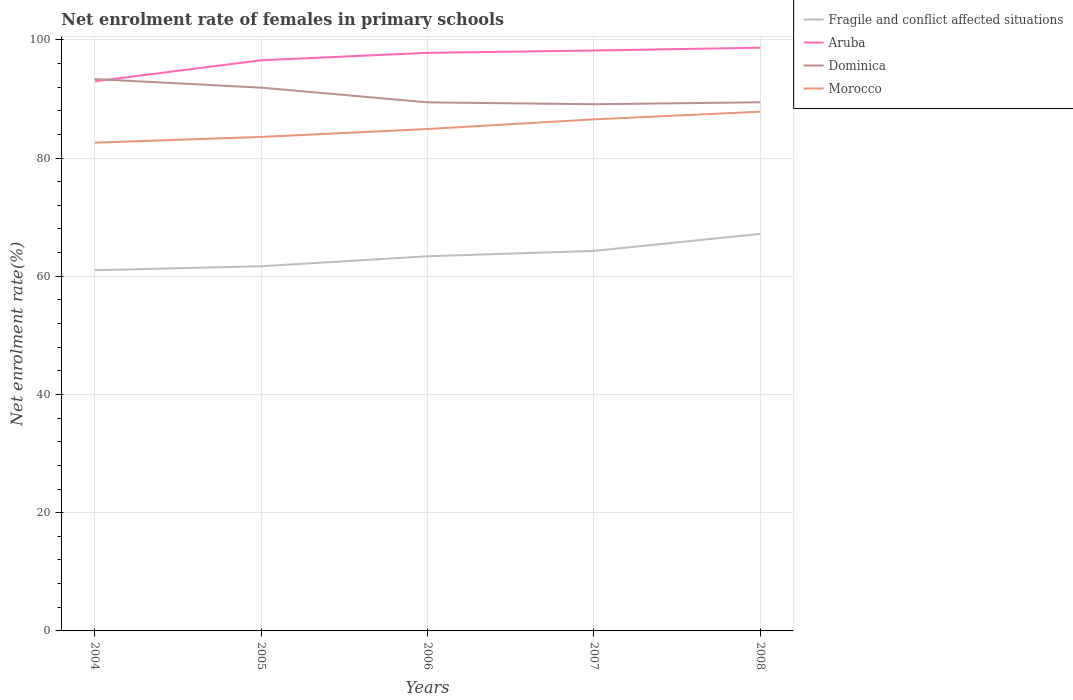Does the line corresponding to Dominica intersect with the line corresponding to Fragile and conflict affected situations?
Give a very brief answer. No. Is the number of lines equal to the number of legend labels?
Offer a very short reply. Yes. Across all years, what is the maximum net enrolment rate of females in primary schools in Fragile and conflict affected situations?
Your answer should be compact. 61.02. What is the total net enrolment rate of females in primary schools in Fragile and conflict affected situations in the graph?
Provide a short and direct response. -5.48. What is the difference between the highest and the second highest net enrolment rate of females in primary schools in Fragile and conflict affected situations?
Offer a very short reply. 6.15. What is the difference between the highest and the lowest net enrolment rate of females in primary schools in Fragile and conflict affected situations?
Your answer should be compact. 2. How many lines are there?
Give a very brief answer. 4. What is the difference between two consecutive major ticks on the Y-axis?
Your answer should be very brief. 20. Are the values on the major ticks of Y-axis written in scientific E-notation?
Provide a succinct answer. No. How many legend labels are there?
Offer a terse response. 4. What is the title of the graph?
Your answer should be very brief. Net enrolment rate of females in primary schools. Does "Madagascar" appear as one of the legend labels in the graph?
Give a very brief answer. No. What is the label or title of the X-axis?
Keep it short and to the point. Years. What is the label or title of the Y-axis?
Your answer should be compact. Net enrolment rate(%). What is the Net enrolment rate(%) of Fragile and conflict affected situations in 2004?
Your answer should be compact. 61.02. What is the Net enrolment rate(%) in Aruba in 2004?
Keep it short and to the point. 92.98. What is the Net enrolment rate(%) of Dominica in 2004?
Make the answer very short. 93.36. What is the Net enrolment rate(%) of Morocco in 2004?
Offer a terse response. 82.59. What is the Net enrolment rate(%) in Fragile and conflict affected situations in 2005?
Provide a succinct answer. 61.69. What is the Net enrolment rate(%) of Aruba in 2005?
Your answer should be very brief. 96.54. What is the Net enrolment rate(%) of Dominica in 2005?
Offer a terse response. 91.91. What is the Net enrolment rate(%) of Morocco in 2005?
Your answer should be compact. 83.57. What is the Net enrolment rate(%) in Fragile and conflict affected situations in 2006?
Your answer should be very brief. 63.38. What is the Net enrolment rate(%) in Aruba in 2006?
Keep it short and to the point. 97.8. What is the Net enrolment rate(%) of Dominica in 2006?
Your answer should be compact. 89.42. What is the Net enrolment rate(%) of Morocco in 2006?
Provide a succinct answer. 84.91. What is the Net enrolment rate(%) of Fragile and conflict affected situations in 2007?
Give a very brief answer. 64.29. What is the Net enrolment rate(%) in Aruba in 2007?
Keep it short and to the point. 98.19. What is the Net enrolment rate(%) in Dominica in 2007?
Your response must be concise. 89.1. What is the Net enrolment rate(%) in Morocco in 2007?
Your response must be concise. 86.54. What is the Net enrolment rate(%) of Fragile and conflict affected situations in 2008?
Your response must be concise. 67.17. What is the Net enrolment rate(%) of Aruba in 2008?
Your answer should be very brief. 98.67. What is the Net enrolment rate(%) in Dominica in 2008?
Ensure brevity in your answer.  89.43. What is the Net enrolment rate(%) of Morocco in 2008?
Provide a succinct answer. 87.84. Across all years, what is the maximum Net enrolment rate(%) in Fragile and conflict affected situations?
Provide a short and direct response. 67.17. Across all years, what is the maximum Net enrolment rate(%) in Aruba?
Give a very brief answer. 98.67. Across all years, what is the maximum Net enrolment rate(%) of Dominica?
Ensure brevity in your answer.  93.36. Across all years, what is the maximum Net enrolment rate(%) in Morocco?
Your answer should be very brief. 87.84. Across all years, what is the minimum Net enrolment rate(%) of Fragile and conflict affected situations?
Offer a terse response. 61.02. Across all years, what is the minimum Net enrolment rate(%) in Aruba?
Give a very brief answer. 92.98. Across all years, what is the minimum Net enrolment rate(%) in Dominica?
Offer a very short reply. 89.1. Across all years, what is the minimum Net enrolment rate(%) in Morocco?
Give a very brief answer. 82.59. What is the total Net enrolment rate(%) of Fragile and conflict affected situations in the graph?
Your answer should be very brief. 317.56. What is the total Net enrolment rate(%) of Aruba in the graph?
Ensure brevity in your answer.  484.17. What is the total Net enrolment rate(%) in Dominica in the graph?
Offer a very short reply. 453.22. What is the total Net enrolment rate(%) of Morocco in the graph?
Make the answer very short. 425.46. What is the difference between the Net enrolment rate(%) in Fragile and conflict affected situations in 2004 and that in 2005?
Your answer should be compact. -0.67. What is the difference between the Net enrolment rate(%) of Aruba in 2004 and that in 2005?
Give a very brief answer. -3.57. What is the difference between the Net enrolment rate(%) in Dominica in 2004 and that in 2005?
Your response must be concise. 1.45. What is the difference between the Net enrolment rate(%) in Morocco in 2004 and that in 2005?
Your response must be concise. -0.98. What is the difference between the Net enrolment rate(%) of Fragile and conflict affected situations in 2004 and that in 2006?
Offer a very short reply. -2.36. What is the difference between the Net enrolment rate(%) in Aruba in 2004 and that in 2006?
Make the answer very short. -4.82. What is the difference between the Net enrolment rate(%) in Dominica in 2004 and that in 2006?
Make the answer very short. 3.94. What is the difference between the Net enrolment rate(%) of Morocco in 2004 and that in 2006?
Keep it short and to the point. -2.32. What is the difference between the Net enrolment rate(%) of Fragile and conflict affected situations in 2004 and that in 2007?
Provide a short and direct response. -3.27. What is the difference between the Net enrolment rate(%) of Aruba in 2004 and that in 2007?
Provide a short and direct response. -5.22. What is the difference between the Net enrolment rate(%) in Dominica in 2004 and that in 2007?
Provide a short and direct response. 4.26. What is the difference between the Net enrolment rate(%) in Morocco in 2004 and that in 2007?
Make the answer very short. -3.95. What is the difference between the Net enrolment rate(%) in Fragile and conflict affected situations in 2004 and that in 2008?
Make the answer very short. -6.15. What is the difference between the Net enrolment rate(%) in Aruba in 2004 and that in 2008?
Provide a succinct answer. -5.69. What is the difference between the Net enrolment rate(%) in Dominica in 2004 and that in 2008?
Provide a short and direct response. 3.93. What is the difference between the Net enrolment rate(%) of Morocco in 2004 and that in 2008?
Make the answer very short. -5.24. What is the difference between the Net enrolment rate(%) in Fragile and conflict affected situations in 2005 and that in 2006?
Provide a short and direct response. -1.69. What is the difference between the Net enrolment rate(%) in Aruba in 2005 and that in 2006?
Make the answer very short. -1.26. What is the difference between the Net enrolment rate(%) in Dominica in 2005 and that in 2006?
Offer a terse response. 2.49. What is the difference between the Net enrolment rate(%) of Morocco in 2005 and that in 2006?
Offer a terse response. -1.34. What is the difference between the Net enrolment rate(%) in Fragile and conflict affected situations in 2005 and that in 2007?
Make the answer very short. -2.6. What is the difference between the Net enrolment rate(%) of Aruba in 2005 and that in 2007?
Your answer should be very brief. -1.65. What is the difference between the Net enrolment rate(%) of Dominica in 2005 and that in 2007?
Give a very brief answer. 2.81. What is the difference between the Net enrolment rate(%) of Morocco in 2005 and that in 2007?
Your answer should be compact. -2.97. What is the difference between the Net enrolment rate(%) in Fragile and conflict affected situations in 2005 and that in 2008?
Provide a short and direct response. -5.48. What is the difference between the Net enrolment rate(%) of Aruba in 2005 and that in 2008?
Keep it short and to the point. -2.12. What is the difference between the Net enrolment rate(%) of Dominica in 2005 and that in 2008?
Ensure brevity in your answer.  2.48. What is the difference between the Net enrolment rate(%) in Morocco in 2005 and that in 2008?
Your response must be concise. -4.27. What is the difference between the Net enrolment rate(%) of Fragile and conflict affected situations in 2006 and that in 2007?
Ensure brevity in your answer.  -0.91. What is the difference between the Net enrolment rate(%) in Aruba in 2006 and that in 2007?
Your answer should be compact. -0.39. What is the difference between the Net enrolment rate(%) in Dominica in 2006 and that in 2007?
Give a very brief answer. 0.32. What is the difference between the Net enrolment rate(%) of Morocco in 2006 and that in 2007?
Ensure brevity in your answer.  -1.63. What is the difference between the Net enrolment rate(%) in Fragile and conflict affected situations in 2006 and that in 2008?
Make the answer very short. -3.79. What is the difference between the Net enrolment rate(%) of Aruba in 2006 and that in 2008?
Make the answer very short. -0.87. What is the difference between the Net enrolment rate(%) in Dominica in 2006 and that in 2008?
Keep it short and to the point. -0.01. What is the difference between the Net enrolment rate(%) of Morocco in 2006 and that in 2008?
Your answer should be compact. -2.93. What is the difference between the Net enrolment rate(%) of Fragile and conflict affected situations in 2007 and that in 2008?
Your answer should be very brief. -2.89. What is the difference between the Net enrolment rate(%) in Aruba in 2007 and that in 2008?
Your response must be concise. -0.48. What is the difference between the Net enrolment rate(%) of Dominica in 2007 and that in 2008?
Offer a terse response. -0.33. What is the difference between the Net enrolment rate(%) of Morocco in 2007 and that in 2008?
Your answer should be compact. -1.29. What is the difference between the Net enrolment rate(%) of Fragile and conflict affected situations in 2004 and the Net enrolment rate(%) of Aruba in 2005?
Keep it short and to the point. -35.52. What is the difference between the Net enrolment rate(%) in Fragile and conflict affected situations in 2004 and the Net enrolment rate(%) in Dominica in 2005?
Offer a terse response. -30.89. What is the difference between the Net enrolment rate(%) of Fragile and conflict affected situations in 2004 and the Net enrolment rate(%) of Morocco in 2005?
Your answer should be very brief. -22.55. What is the difference between the Net enrolment rate(%) in Aruba in 2004 and the Net enrolment rate(%) in Dominica in 2005?
Give a very brief answer. 1.07. What is the difference between the Net enrolment rate(%) in Aruba in 2004 and the Net enrolment rate(%) in Morocco in 2005?
Your answer should be compact. 9.4. What is the difference between the Net enrolment rate(%) of Dominica in 2004 and the Net enrolment rate(%) of Morocco in 2005?
Ensure brevity in your answer.  9.79. What is the difference between the Net enrolment rate(%) in Fragile and conflict affected situations in 2004 and the Net enrolment rate(%) in Aruba in 2006?
Give a very brief answer. -36.77. What is the difference between the Net enrolment rate(%) in Fragile and conflict affected situations in 2004 and the Net enrolment rate(%) in Dominica in 2006?
Your answer should be very brief. -28.4. What is the difference between the Net enrolment rate(%) of Fragile and conflict affected situations in 2004 and the Net enrolment rate(%) of Morocco in 2006?
Offer a very short reply. -23.89. What is the difference between the Net enrolment rate(%) in Aruba in 2004 and the Net enrolment rate(%) in Dominica in 2006?
Offer a terse response. 3.56. What is the difference between the Net enrolment rate(%) in Aruba in 2004 and the Net enrolment rate(%) in Morocco in 2006?
Give a very brief answer. 8.07. What is the difference between the Net enrolment rate(%) in Dominica in 2004 and the Net enrolment rate(%) in Morocco in 2006?
Offer a terse response. 8.45. What is the difference between the Net enrolment rate(%) of Fragile and conflict affected situations in 2004 and the Net enrolment rate(%) of Aruba in 2007?
Keep it short and to the point. -37.17. What is the difference between the Net enrolment rate(%) in Fragile and conflict affected situations in 2004 and the Net enrolment rate(%) in Dominica in 2007?
Keep it short and to the point. -28.08. What is the difference between the Net enrolment rate(%) in Fragile and conflict affected situations in 2004 and the Net enrolment rate(%) in Morocco in 2007?
Provide a short and direct response. -25.52. What is the difference between the Net enrolment rate(%) of Aruba in 2004 and the Net enrolment rate(%) of Dominica in 2007?
Offer a very short reply. 3.87. What is the difference between the Net enrolment rate(%) of Aruba in 2004 and the Net enrolment rate(%) of Morocco in 2007?
Provide a short and direct response. 6.43. What is the difference between the Net enrolment rate(%) in Dominica in 2004 and the Net enrolment rate(%) in Morocco in 2007?
Ensure brevity in your answer.  6.82. What is the difference between the Net enrolment rate(%) of Fragile and conflict affected situations in 2004 and the Net enrolment rate(%) of Aruba in 2008?
Offer a very short reply. -37.64. What is the difference between the Net enrolment rate(%) of Fragile and conflict affected situations in 2004 and the Net enrolment rate(%) of Dominica in 2008?
Provide a short and direct response. -28.41. What is the difference between the Net enrolment rate(%) of Fragile and conflict affected situations in 2004 and the Net enrolment rate(%) of Morocco in 2008?
Offer a terse response. -26.81. What is the difference between the Net enrolment rate(%) of Aruba in 2004 and the Net enrolment rate(%) of Dominica in 2008?
Your answer should be very brief. 3.54. What is the difference between the Net enrolment rate(%) of Aruba in 2004 and the Net enrolment rate(%) of Morocco in 2008?
Keep it short and to the point. 5.14. What is the difference between the Net enrolment rate(%) of Dominica in 2004 and the Net enrolment rate(%) of Morocco in 2008?
Give a very brief answer. 5.52. What is the difference between the Net enrolment rate(%) in Fragile and conflict affected situations in 2005 and the Net enrolment rate(%) in Aruba in 2006?
Make the answer very short. -36.11. What is the difference between the Net enrolment rate(%) in Fragile and conflict affected situations in 2005 and the Net enrolment rate(%) in Dominica in 2006?
Your answer should be compact. -27.73. What is the difference between the Net enrolment rate(%) in Fragile and conflict affected situations in 2005 and the Net enrolment rate(%) in Morocco in 2006?
Your answer should be very brief. -23.22. What is the difference between the Net enrolment rate(%) of Aruba in 2005 and the Net enrolment rate(%) of Dominica in 2006?
Your answer should be very brief. 7.12. What is the difference between the Net enrolment rate(%) in Aruba in 2005 and the Net enrolment rate(%) in Morocco in 2006?
Provide a succinct answer. 11.63. What is the difference between the Net enrolment rate(%) in Dominica in 2005 and the Net enrolment rate(%) in Morocco in 2006?
Ensure brevity in your answer.  7. What is the difference between the Net enrolment rate(%) of Fragile and conflict affected situations in 2005 and the Net enrolment rate(%) of Aruba in 2007?
Your answer should be compact. -36.5. What is the difference between the Net enrolment rate(%) of Fragile and conflict affected situations in 2005 and the Net enrolment rate(%) of Dominica in 2007?
Provide a short and direct response. -27.41. What is the difference between the Net enrolment rate(%) in Fragile and conflict affected situations in 2005 and the Net enrolment rate(%) in Morocco in 2007?
Your answer should be compact. -24.85. What is the difference between the Net enrolment rate(%) in Aruba in 2005 and the Net enrolment rate(%) in Dominica in 2007?
Give a very brief answer. 7.44. What is the difference between the Net enrolment rate(%) in Aruba in 2005 and the Net enrolment rate(%) in Morocco in 2007?
Ensure brevity in your answer.  10. What is the difference between the Net enrolment rate(%) of Dominica in 2005 and the Net enrolment rate(%) of Morocco in 2007?
Provide a short and direct response. 5.37. What is the difference between the Net enrolment rate(%) in Fragile and conflict affected situations in 2005 and the Net enrolment rate(%) in Aruba in 2008?
Your answer should be compact. -36.97. What is the difference between the Net enrolment rate(%) of Fragile and conflict affected situations in 2005 and the Net enrolment rate(%) of Dominica in 2008?
Give a very brief answer. -27.74. What is the difference between the Net enrolment rate(%) of Fragile and conflict affected situations in 2005 and the Net enrolment rate(%) of Morocco in 2008?
Offer a very short reply. -26.14. What is the difference between the Net enrolment rate(%) of Aruba in 2005 and the Net enrolment rate(%) of Dominica in 2008?
Make the answer very short. 7.11. What is the difference between the Net enrolment rate(%) in Aruba in 2005 and the Net enrolment rate(%) in Morocco in 2008?
Ensure brevity in your answer.  8.7. What is the difference between the Net enrolment rate(%) of Dominica in 2005 and the Net enrolment rate(%) of Morocco in 2008?
Ensure brevity in your answer.  4.07. What is the difference between the Net enrolment rate(%) of Fragile and conflict affected situations in 2006 and the Net enrolment rate(%) of Aruba in 2007?
Provide a short and direct response. -34.81. What is the difference between the Net enrolment rate(%) of Fragile and conflict affected situations in 2006 and the Net enrolment rate(%) of Dominica in 2007?
Provide a short and direct response. -25.72. What is the difference between the Net enrolment rate(%) of Fragile and conflict affected situations in 2006 and the Net enrolment rate(%) of Morocco in 2007?
Offer a very short reply. -23.16. What is the difference between the Net enrolment rate(%) of Aruba in 2006 and the Net enrolment rate(%) of Dominica in 2007?
Keep it short and to the point. 8.7. What is the difference between the Net enrolment rate(%) of Aruba in 2006 and the Net enrolment rate(%) of Morocco in 2007?
Your answer should be very brief. 11.25. What is the difference between the Net enrolment rate(%) in Dominica in 2006 and the Net enrolment rate(%) in Morocco in 2007?
Offer a terse response. 2.88. What is the difference between the Net enrolment rate(%) of Fragile and conflict affected situations in 2006 and the Net enrolment rate(%) of Aruba in 2008?
Your answer should be very brief. -35.28. What is the difference between the Net enrolment rate(%) of Fragile and conflict affected situations in 2006 and the Net enrolment rate(%) of Dominica in 2008?
Offer a terse response. -26.05. What is the difference between the Net enrolment rate(%) in Fragile and conflict affected situations in 2006 and the Net enrolment rate(%) in Morocco in 2008?
Your answer should be compact. -24.45. What is the difference between the Net enrolment rate(%) of Aruba in 2006 and the Net enrolment rate(%) of Dominica in 2008?
Offer a very short reply. 8.37. What is the difference between the Net enrolment rate(%) of Aruba in 2006 and the Net enrolment rate(%) of Morocco in 2008?
Keep it short and to the point. 9.96. What is the difference between the Net enrolment rate(%) in Dominica in 2006 and the Net enrolment rate(%) in Morocco in 2008?
Offer a very short reply. 1.58. What is the difference between the Net enrolment rate(%) of Fragile and conflict affected situations in 2007 and the Net enrolment rate(%) of Aruba in 2008?
Offer a very short reply. -34.38. What is the difference between the Net enrolment rate(%) of Fragile and conflict affected situations in 2007 and the Net enrolment rate(%) of Dominica in 2008?
Ensure brevity in your answer.  -25.14. What is the difference between the Net enrolment rate(%) of Fragile and conflict affected situations in 2007 and the Net enrolment rate(%) of Morocco in 2008?
Provide a succinct answer. -23.55. What is the difference between the Net enrolment rate(%) of Aruba in 2007 and the Net enrolment rate(%) of Dominica in 2008?
Your answer should be compact. 8.76. What is the difference between the Net enrolment rate(%) of Aruba in 2007 and the Net enrolment rate(%) of Morocco in 2008?
Make the answer very short. 10.35. What is the difference between the Net enrolment rate(%) of Dominica in 2007 and the Net enrolment rate(%) of Morocco in 2008?
Your answer should be very brief. 1.26. What is the average Net enrolment rate(%) of Fragile and conflict affected situations per year?
Your response must be concise. 63.51. What is the average Net enrolment rate(%) in Aruba per year?
Offer a terse response. 96.83. What is the average Net enrolment rate(%) in Dominica per year?
Your answer should be very brief. 90.64. What is the average Net enrolment rate(%) in Morocco per year?
Provide a short and direct response. 85.09. In the year 2004, what is the difference between the Net enrolment rate(%) of Fragile and conflict affected situations and Net enrolment rate(%) of Aruba?
Give a very brief answer. -31.95. In the year 2004, what is the difference between the Net enrolment rate(%) in Fragile and conflict affected situations and Net enrolment rate(%) in Dominica?
Your response must be concise. -32.34. In the year 2004, what is the difference between the Net enrolment rate(%) in Fragile and conflict affected situations and Net enrolment rate(%) in Morocco?
Your response must be concise. -21.57. In the year 2004, what is the difference between the Net enrolment rate(%) of Aruba and Net enrolment rate(%) of Dominica?
Give a very brief answer. -0.38. In the year 2004, what is the difference between the Net enrolment rate(%) of Aruba and Net enrolment rate(%) of Morocco?
Offer a very short reply. 10.38. In the year 2004, what is the difference between the Net enrolment rate(%) in Dominica and Net enrolment rate(%) in Morocco?
Keep it short and to the point. 10.77. In the year 2005, what is the difference between the Net enrolment rate(%) of Fragile and conflict affected situations and Net enrolment rate(%) of Aruba?
Offer a terse response. -34.85. In the year 2005, what is the difference between the Net enrolment rate(%) of Fragile and conflict affected situations and Net enrolment rate(%) of Dominica?
Provide a succinct answer. -30.22. In the year 2005, what is the difference between the Net enrolment rate(%) in Fragile and conflict affected situations and Net enrolment rate(%) in Morocco?
Your response must be concise. -21.88. In the year 2005, what is the difference between the Net enrolment rate(%) in Aruba and Net enrolment rate(%) in Dominica?
Offer a terse response. 4.63. In the year 2005, what is the difference between the Net enrolment rate(%) in Aruba and Net enrolment rate(%) in Morocco?
Keep it short and to the point. 12.97. In the year 2005, what is the difference between the Net enrolment rate(%) of Dominica and Net enrolment rate(%) of Morocco?
Keep it short and to the point. 8.34. In the year 2006, what is the difference between the Net enrolment rate(%) in Fragile and conflict affected situations and Net enrolment rate(%) in Aruba?
Offer a very short reply. -34.41. In the year 2006, what is the difference between the Net enrolment rate(%) of Fragile and conflict affected situations and Net enrolment rate(%) of Dominica?
Offer a terse response. -26.04. In the year 2006, what is the difference between the Net enrolment rate(%) of Fragile and conflict affected situations and Net enrolment rate(%) of Morocco?
Offer a terse response. -21.53. In the year 2006, what is the difference between the Net enrolment rate(%) in Aruba and Net enrolment rate(%) in Dominica?
Your answer should be compact. 8.38. In the year 2006, what is the difference between the Net enrolment rate(%) of Aruba and Net enrolment rate(%) of Morocco?
Keep it short and to the point. 12.89. In the year 2006, what is the difference between the Net enrolment rate(%) of Dominica and Net enrolment rate(%) of Morocco?
Provide a short and direct response. 4.51. In the year 2007, what is the difference between the Net enrolment rate(%) of Fragile and conflict affected situations and Net enrolment rate(%) of Aruba?
Offer a very short reply. -33.9. In the year 2007, what is the difference between the Net enrolment rate(%) in Fragile and conflict affected situations and Net enrolment rate(%) in Dominica?
Your response must be concise. -24.81. In the year 2007, what is the difference between the Net enrolment rate(%) of Fragile and conflict affected situations and Net enrolment rate(%) of Morocco?
Give a very brief answer. -22.26. In the year 2007, what is the difference between the Net enrolment rate(%) of Aruba and Net enrolment rate(%) of Dominica?
Provide a short and direct response. 9.09. In the year 2007, what is the difference between the Net enrolment rate(%) of Aruba and Net enrolment rate(%) of Morocco?
Offer a very short reply. 11.65. In the year 2007, what is the difference between the Net enrolment rate(%) of Dominica and Net enrolment rate(%) of Morocco?
Keep it short and to the point. 2.56. In the year 2008, what is the difference between the Net enrolment rate(%) in Fragile and conflict affected situations and Net enrolment rate(%) in Aruba?
Make the answer very short. -31.49. In the year 2008, what is the difference between the Net enrolment rate(%) of Fragile and conflict affected situations and Net enrolment rate(%) of Dominica?
Your response must be concise. -22.26. In the year 2008, what is the difference between the Net enrolment rate(%) in Fragile and conflict affected situations and Net enrolment rate(%) in Morocco?
Make the answer very short. -20.66. In the year 2008, what is the difference between the Net enrolment rate(%) in Aruba and Net enrolment rate(%) in Dominica?
Offer a terse response. 9.23. In the year 2008, what is the difference between the Net enrolment rate(%) of Aruba and Net enrolment rate(%) of Morocco?
Your answer should be very brief. 10.83. In the year 2008, what is the difference between the Net enrolment rate(%) of Dominica and Net enrolment rate(%) of Morocco?
Your answer should be very brief. 1.6. What is the ratio of the Net enrolment rate(%) of Fragile and conflict affected situations in 2004 to that in 2005?
Keep it short and to the point. 0.99. What is the ratio of the Net enrolment rate(%) in Aruba in 2004 to that in 2005?
Your answer should be compact. 0.96. What is the ratio of the Net enrolment rate(%) of Dominica in 2004 to that in 2005?
Keep it short and to the point. 1.02. What is the ratio of the Net enrolment rate(%) of Morocco in 2004 to that in 2005?
Provide a succinct answer. 0.99. What is the ratio of the Net enrolment rate(%) of Fragile and conflict affected situations in 2004 to that in 2006?
Ensure brevity in your answer.  0.96. What is the ratio of the Net enrolment rate(%) in Aruba in 2004 to that in 2006?
Offer a terse response. 0.95. What is the ratio of the Net enrolment rate(%) in Dominica in 2004 to that in 2006?
Keep it short and to the point. 1.04. What is the ratio of the Net enrolment rate(%) of Morocco in 2004 to that in 2006?
Make the answer very short. 0.97. What is the ratio of the Net enrolment rate(%) of Fragile and conflict affected situations in 2004 to that in 2007?
Your answer should be compact. 0.95. What is the ratio of the Net enrolment rate(%) in Aruba in 2004 to that in 2007?
Keep it short and to the point. 0.95. What is the ratio of the Net enrolment rate(%) in Dominica in 2004 to that in 2007?
Offer a very short reply. 1.05. What is the ratio of the Net enrolment rate(%) of Morocco in 2004 to that in 2007?
Your answer should be compact. 0.95. What is the ratio of the Net enrolment rate(%) of Fragile and conflict affected situations in 2004 to that in 2008?
Give a very brief answer. 0.91. What is the ratio of the Net enrolment rate(%) of Aruba in 2004 to that in 2008?
Make the answer very short. 0.94. What is the ratio of the Net enrolment rate(%) of Dominica in 2004 to that in 2008?
Keep it short and to the point. 1.04. What is the ratio of the Net enrolment rate(%) in Morocco in 2004 to that in 2008?
Make the answer very short. 0.94. What is the ratio of the Net enrolment rate(%) of Fragile and conflict affected situations in 2005 to that in 2006?
Your answer should be very brief. 0.97. What is the ratio of the Net enrolment rate(%) of Aruba in 2005 to that in 2006?
Offer a very short reply. 0.99. What is the ratio of the Net enrolment rate(%) in Dominica in 2005 to that in 2006?
Your answer should be compact. 1.03. What is the ratio of the Net enrolment rate(%) of Morocco in 2005 to that in 2006?
Give a very brief answer. 0.98. What is the ratio of the Net enrolment rate(%) in Fragile and conflict affected situations in 2005 to that in 2007?
Provide a succinct answer. 0.96. What is the ratio of the Net enrolment rate(%) in Aruba in 2005 to that in 2007?
Keep it short and to the point. 0.98. What is the ratio of the Net enrolment rate(%) of Dominica in 2005 to that in 2007?
Keep it short and to the point. 1.03. What is the ratio of the Net enrolment rate(%) of Morocco in 2005 to that in 2007?
Give a very brief answer. 0.97. What is the ratio of the Net enrolment rate(%) of Fragile and conflict affected situations in 2005 to that in 2008?
Your answer should be compact. 0.92. What is the ratio of the Net enrolment rate(%) of Aruba in 2005 to that in 2008?
Make the answer very short. 0.98. What is the ratio of the Net enrolment rate(%) in Dominica in 2005 to that in 2008?
Provide a short and direct response. 1.03. What is the ratio of the Net enrolment rate(%) of Morocco in 2005 to that in 2008?
Make the answer very short. 0.95. What is the ratio of the Net enrolment rate(%) of Fragile and conflict affected situations in 2006 to that in 2007?
Keep it short and to the point. 0.99. What is the ratio of the Net enrolment rate(%) of Aruba in 2006 to that in 2007?
Provide a succinct answer. 1. What is the ratio of the Net enrolment rate(%) of Dominica in 2006 to that in 2007?
Your answer should be very brief. 1. What is the ratio of the Net enrolment rate(%) of Morocco in 2006 to that in 2007?
Your answer should be compact. 0.98. What is the ratio of the Net enrolment rate(%) in Fragile and conflict affected situations in 2006 to that in 2008?
Provide a succinct answer. 0.94. What is the ratio of the Net enrolment rate(%) in Dominica in 2006 to that in 2008?
Offer a very short reply. 1. What is the ratio of the Net enrolment rate(%) of Morocco in 2006 to that in 2008?
Provide a succinct answer. 0.97. What is the ratio of the Net enrolment rate(%) of Aruba in 2007 to that in 2008?
Provide a succinct answer. 1. What is the ratio of the Net enrolment rate(%) of Morocco in 2007 to that in 2008?
Offer a very short reply. 0.99. What is the difference between the highest and the second highest Net enrolment rate(%) in Fragile and conflict affected situations?
Your answer should be compact. 2.89. What is the difference between the highest and the second highest Net enrolment rate(%) of Aruba?
Provide a succinct answer. 0.48. What is the difference between the highest and the second highest Net enrolment rate(%) of Dominica?
Give a very brief answer. 1.45. What is the difference between the highest and the second highest Net enrolment rate(%) of Morocco?
Offer a very short reply. 1.29. What is the difference between the highest and the lowest Net enrolment rate(%) in Fragile and conflict affected situations?
Make the answer very short. 6.15. What is the difference between the highest and the lowest Net enrolment rate(%) of Aruba?
Give a very brief answer. 5.69. What is the difference between the highest and the lowest Net enrolment rate(%) in Dominica?
Make the answer very short. 4.26. What is the difference between the highest and the lowest Net enrolment rate(%) in Morocco?
Offer a terse response. 5.24. 